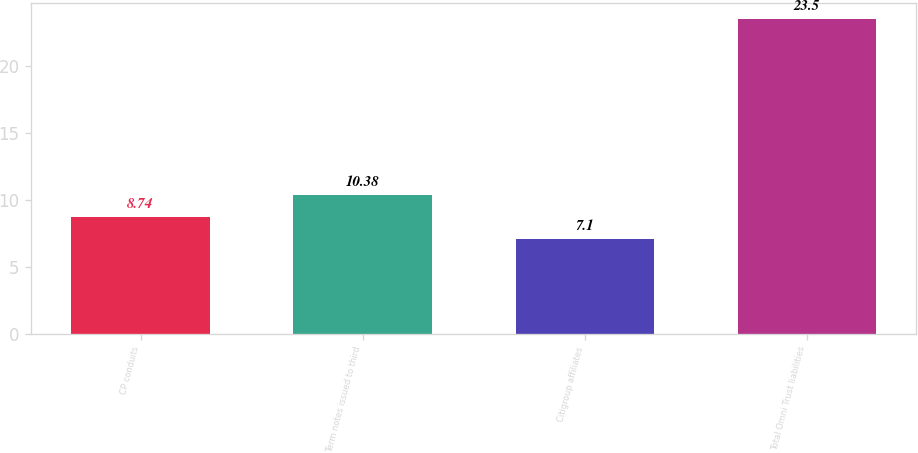Convert chart. <chart><loc_0><loc_0><loc_500><loc_500><bar_chart><fcel>CP conduits<fcel>Term notes issued to third<fcel>Citigroup affiliates<fcel>Total Omni Trust liabilities<nl><fcel>8.74<fcel>10.38<fcel>7.1<fcel>23.5<nl></chart> 